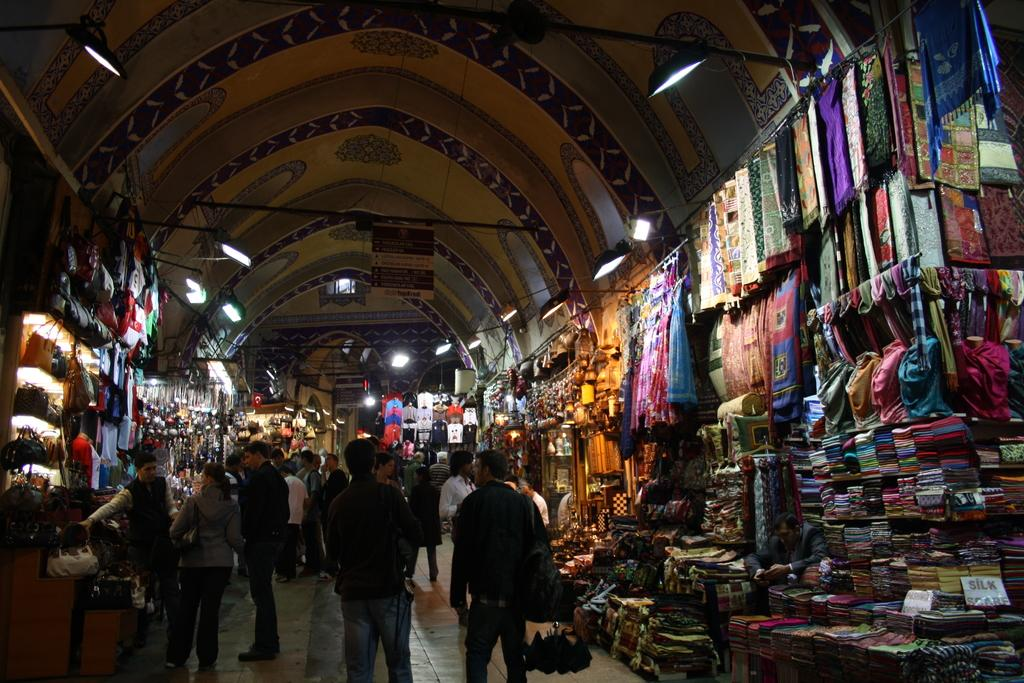What are the people in the image doing? The people in the image are walking on the street. What can be seen in the background of the image? There are lights on the ceiling and clothes visible in the background of the image. Are there any other objects present in the background of the image? Yes, there are other objects present in the background of the image. What type of straw is being used to build the structure in the image? There is no structure or straw present in the image; it features people walking on the street and objects in the background. 